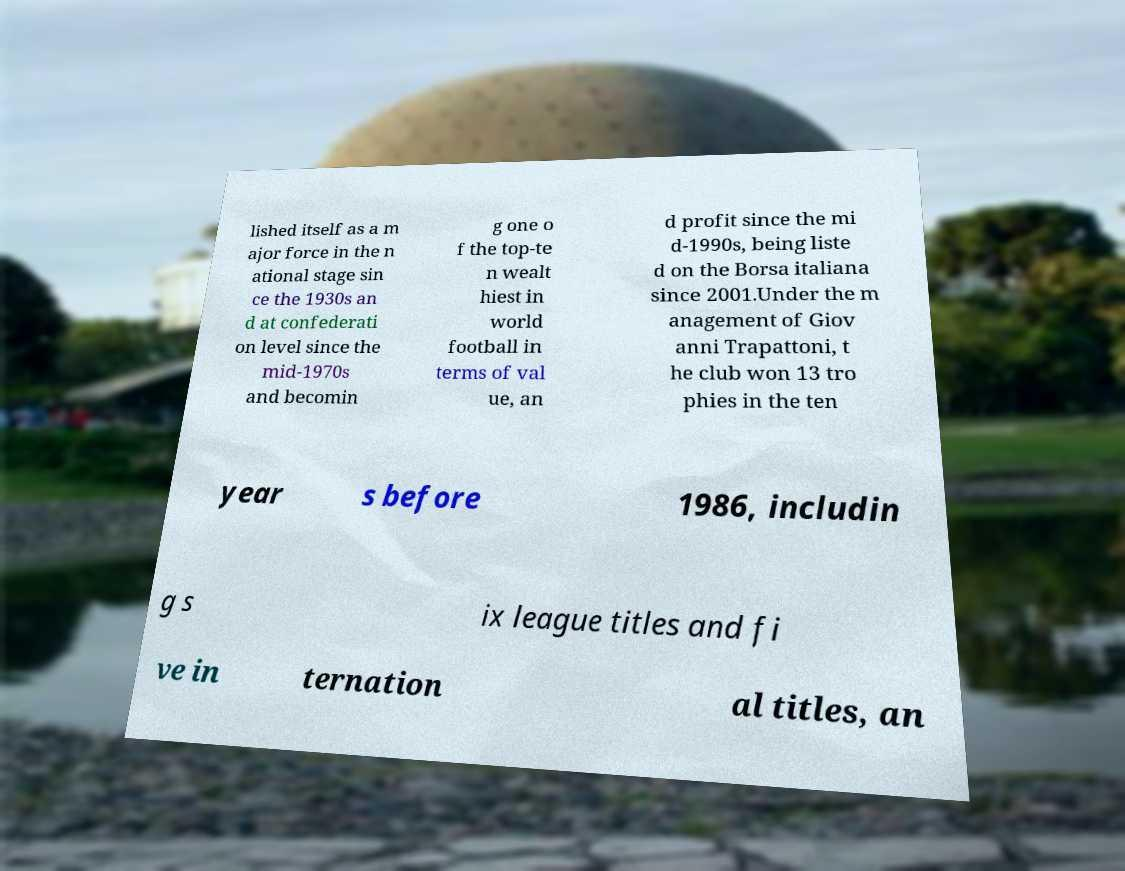Please read and relay the text visible in this image. What does it say? lished itself as a m ajor force in the n ational stage sin ce the 1930s an d at confederati on level since the mid-1970s and becomin g one o f the top-te n wealt hiest in world football in terms of val ue, an d profit since the mi d-1990s, being liste d on the Borsa italiana since 2001.Under the m anagement of Giov anni Trapattoni, t he club won 13 tro phies in the ten year s before 1986, includin g s ix league titles and fi ve in ternation al titles, an 